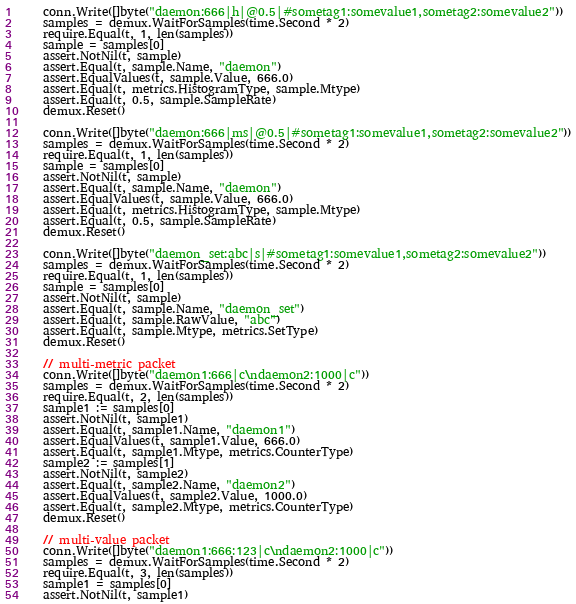Convert code to text. <code><loc_0><loc_0><loc_500><loc_500><_Go_>	conn.Write([]byte("daemon:666|h|@0.5|#sometag1:somevalue1,sometag2:somevalue2"))
	samples = demux.WaitForSamples(time.Second * 2)
	require.Equal(t, 1, len(samples))
	sample = samples[0]
	assert.NotNil(t, sample)
	assert.Equal(t, sample.Name, "daemon")
	assert.EqualValues(t, sample.Value, 666.0)
	assert.Equal(t, metrics.HistogramType, sample.Mtype)
	assert.Equal(t, 0.5, sample.SampleRate)
	demux.Reset()

	conn.Write([]byte("daemon:666|ms|@0.5|#sometag1:somevalue1,sometag2:somevalue2"))
	samples = demux.WaitForSamples(time.Second * 2)
	require.Equal(t, 1, len(samples))
	sample = samples[0]
	assert.NotNil(t, sample)
	assert.Equal(t, sample.Name, "daemon")
	assert.EqualValues(t, sample.Value, 666.0)
	assert.Equal(t, metrics.HistogramType, sample.Mtype)
	assert.Equal(t, 0.5, sample.SampleRate)
	demux.Reset()

	conn.Write([]byte("daemon_set:abc|s|#sometag1:somevalue1,sometag2:somevalue2"))
	samples = demux.WaitForSamples(time.Second * 2)
	require.Equal(t, 1, len(samples))
	sample = samples[0]
	assert.NotNil(t, sample)
	assert.Equal(t, sample.Name, "daemon_set")
	assert.Equal(t, sample.RawValue, "abc")
	assert.Equal(t, sample.Mtype, metrics.SetType)
	demux.Reset()

	// multi-metric packet
	conn.Write([]byte("daemon1:666|c\ndaemon2:1000|c"))
	samples = demux.WaitForSamples(time.Second * 2)
	require.Equal(t, 2, len(samples))
	sample1 := samples[0]
	assert.NotNil(t, sample1)
	assert.Equal(t, sample1.Name, "daemon1")
	assert.EqualValues(t, sample1.Value, 666.0)
	assert.Equal(t, sample1.Mtype, metrics.CounterType)
	sample2 := samples[1]
	assert.NotNil(t, sample2)
	assert.Equal(t, sample2.Name, "daemon2")
	assert.EqualValues(t, sample2.Value, 1000.0)
	assert.Equal(t, sample2.Mtype, metrics.CounterType)
	demux.Reset()

	// multi-value packet
	conn.Write([]byte("daemon1:666:123|c\ndaemon2:1000|c"))
	samples = demux.WaitForSamples(time.Second * 2)
	require.Equal(t, 3, len(samples))
	sample1 = samples[0]
	assert.NotNil(t, sample1)</code> 